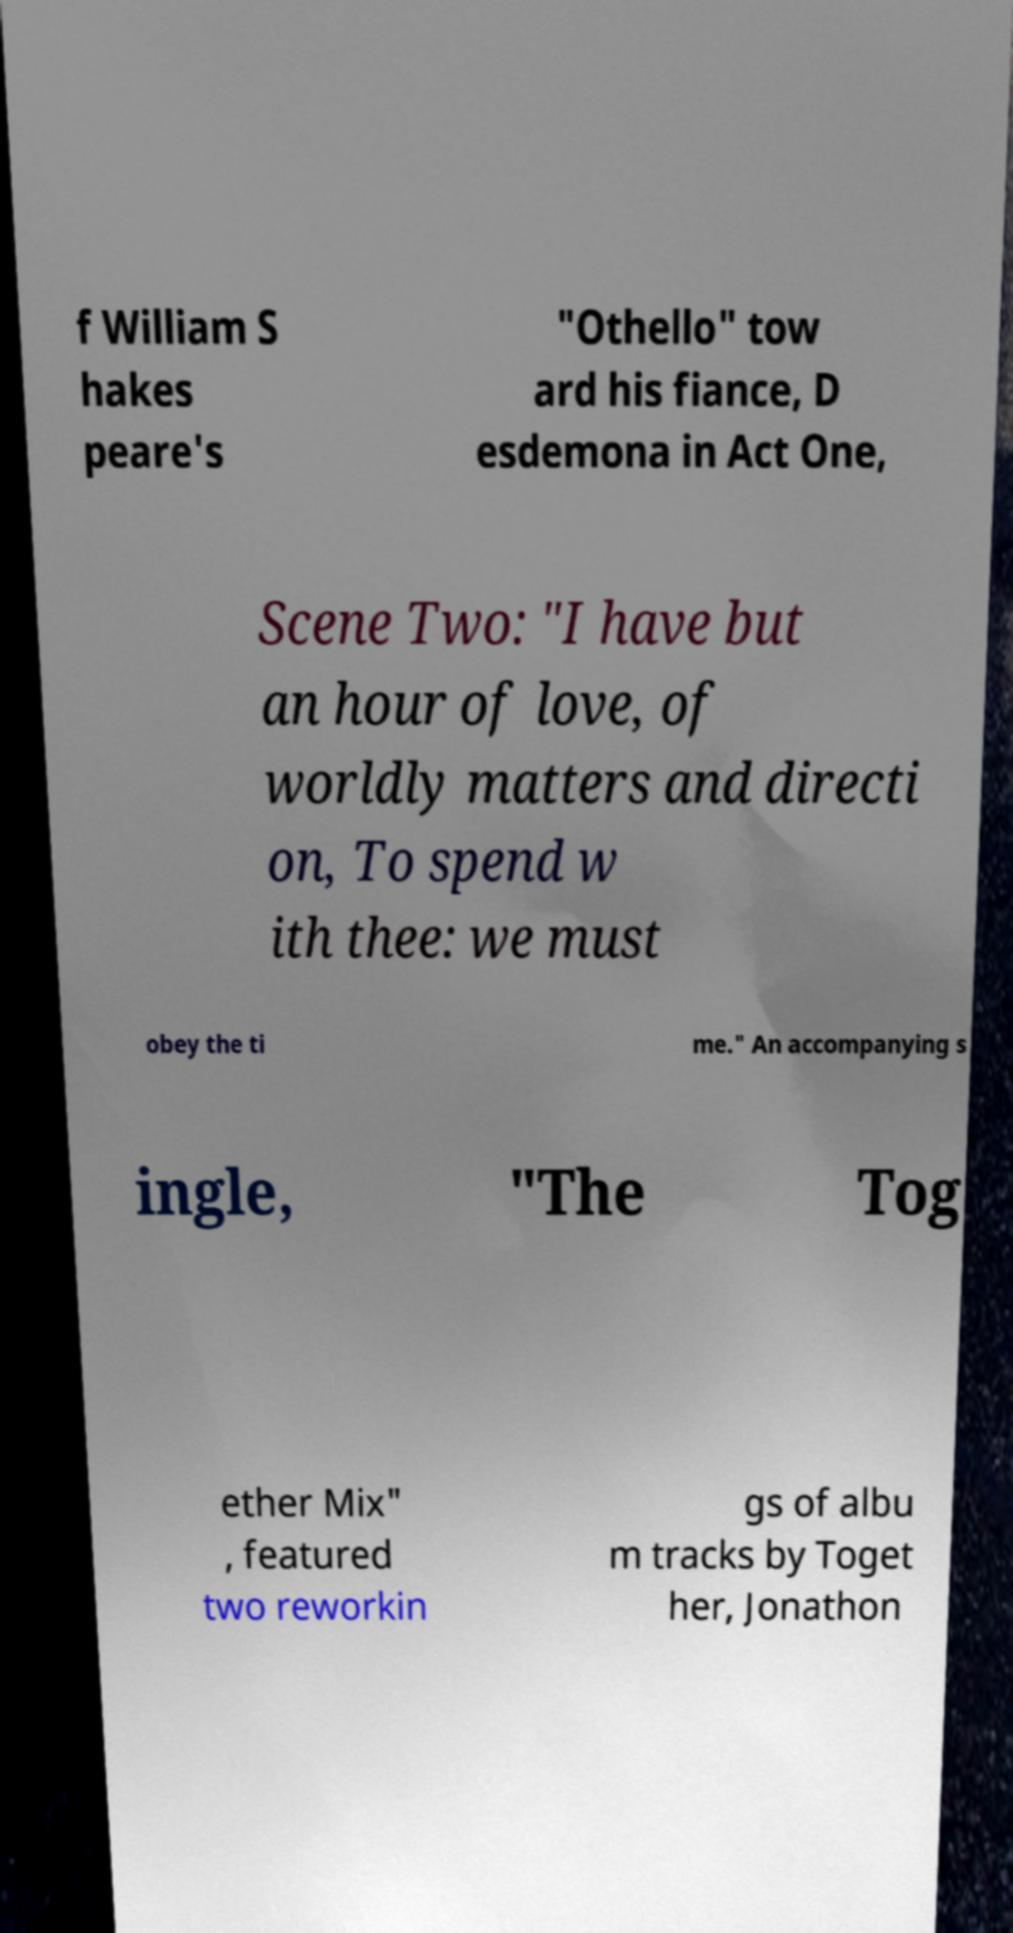Please identify and transcribe the text found in this image. f William S hakes peare's "Othello" tow ard his fiance, D esdemona in Act One, Scene Two: "I have but an hour of love, of worldly matters and directi on, To spend w ith thee: we must obey the ti me." An accompanying s ingle, "The Tog ether Mix" , featured two reworkin gs of albu m tracks by Toget her, Jonathon 